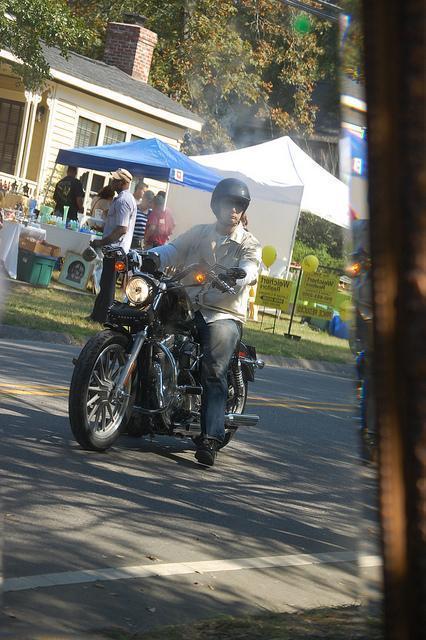What real estate structure is this type of sale often named after?
From the following set of four choices, select the accurate answer to respond to the question.
Options: Patio, cabin, bedroom, garage. Garage. 